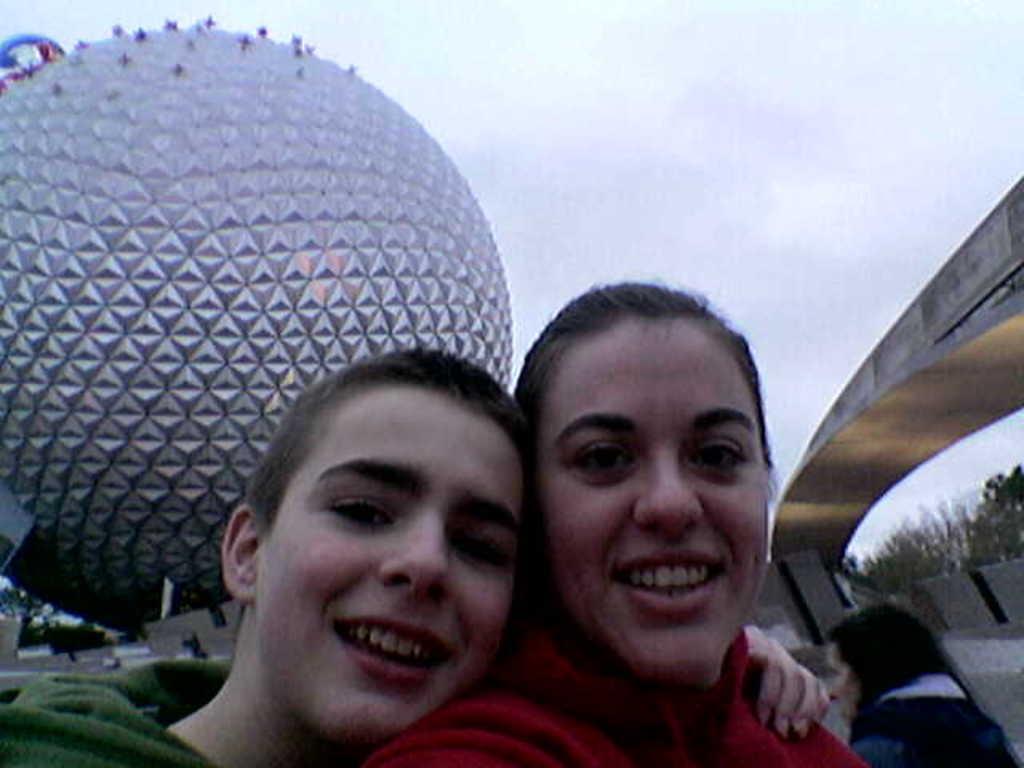In one or two sentences, can you explain what this image depicts? In this picture we can see three persons, behind them there is a big ball, also we can see some trees, and the sky. 